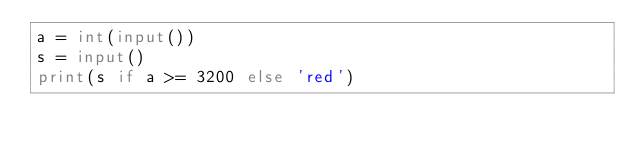<code> <loc_0><loc_0><loc_500><loc_500><_Python_>a = int(input())
s = input()
print(s if a >= 3200 else 'red')</code> 